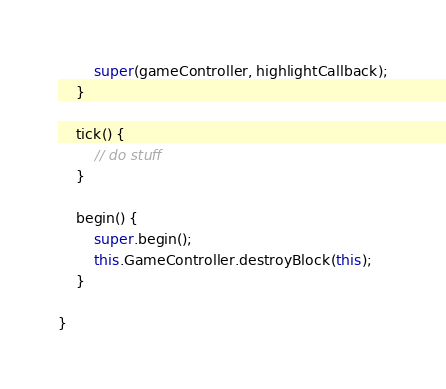<code> <loc_0><loc_0><loc_500><loc_500><_JavaScript_>
        super(gameController, highlightCallback);
    }

    tick() {
        // do stuff
    }

    begin() {
        super.begin();
        this.GameController.destroyBlock(this);
    }

}

</code> 